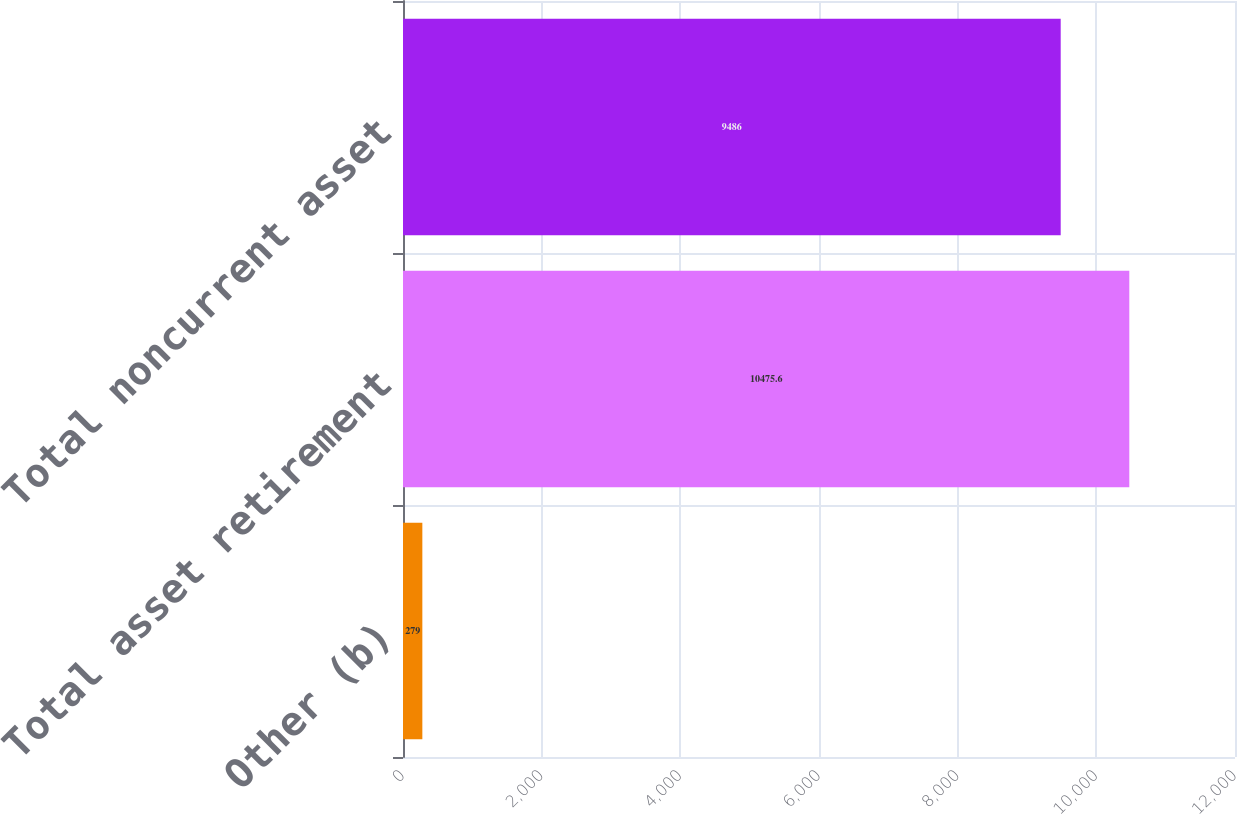Convert chart to OTSL. <chart><loc_0><loc_0><loc_500><loc_500><bar_chart><fcel>Other (b)<fcel>Total asset retirement<fcel>Total noncurrent asset<nl><fcel>279<fcel>10475.6<fcel>9486<nl></chart> 